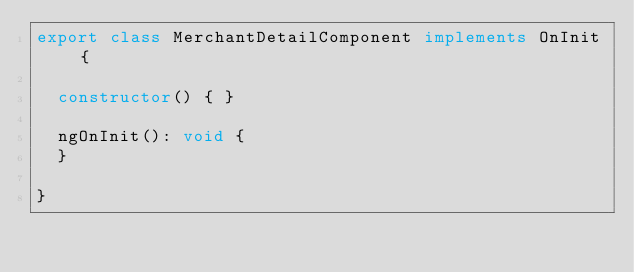Convert code to text. <code><loc_0><loc_0><loc_500><loc_500><_TypeScript_>export class MerchantDetailComponent implements OnInit {

  constructor() { }

  ngOnInit(): void {
  }

}
</code> 